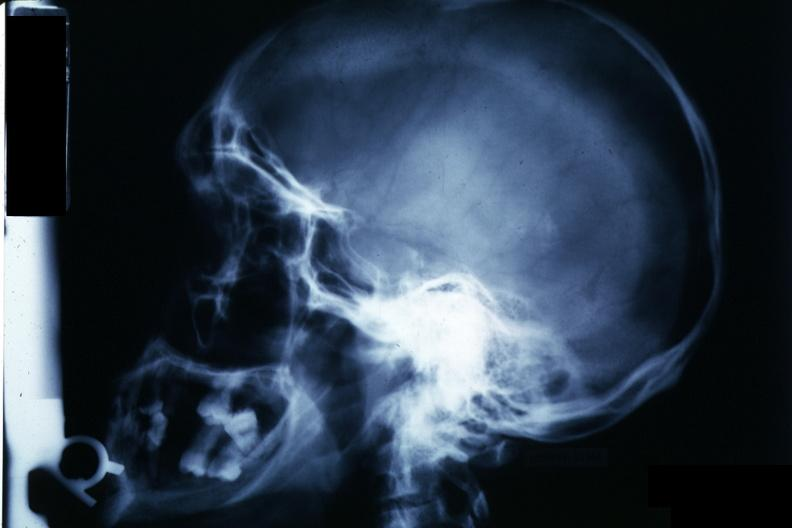s endocrine present?
Answer the question using a single word or phrase. Yes 